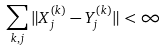<formula> <loc_0><loc_0><loc_500><loc_500>\sum _ { k , j } \| X _ { j } ^ { ( k ) } - Y _ { j } ^ { ( k ) } \| < \infty</formula> 